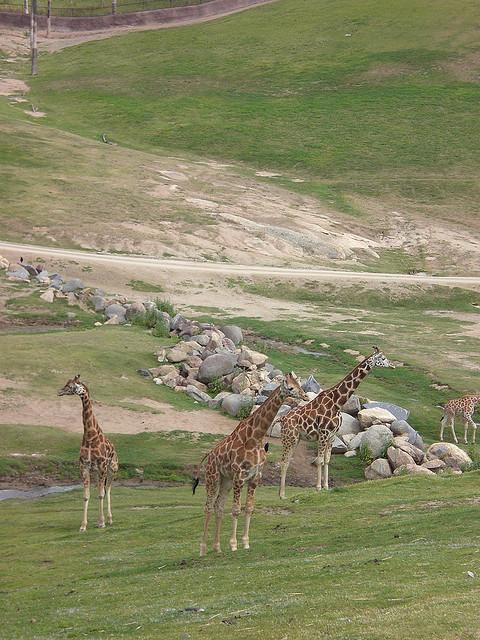Where was this picture taken?
Write a very short answer. Zoo. How many animals are at this location?
Be succinct. 4. Are the animals in this photo typically found in a rainforest?
Answer briefly. No. 